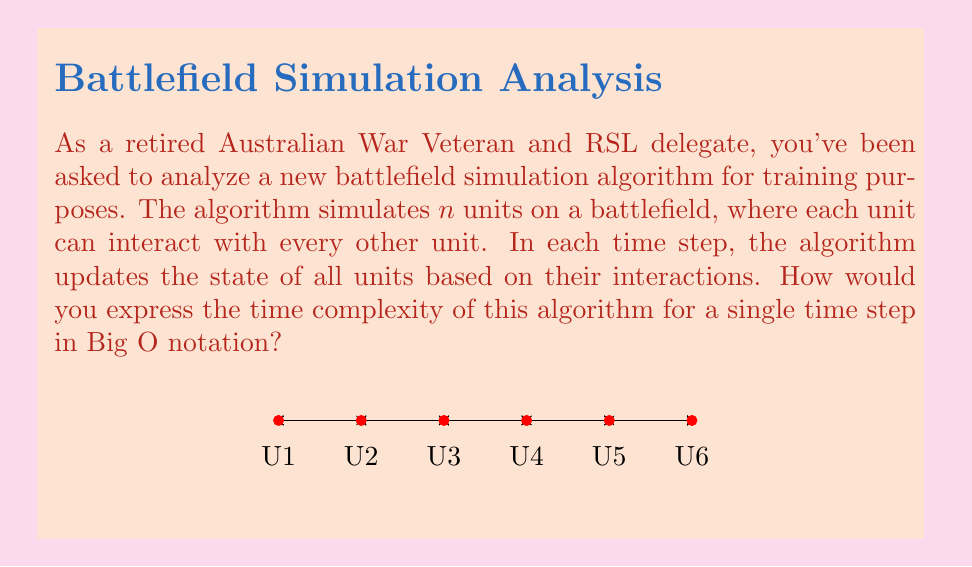Solve this math problem. Let's analyze this step-by-step:

1) In the battlefield simulation, we have $n$ units.

2) Each unit needs to interact with every other unit. This means:
   - Unit 1 interacts with $(n-1)$ units
   - Unit 2 interacts with $(n-1)$ units
   - ...
   - Unit $n$ interacts with $(n-1)$ units

3) The total number of interactions is:

   $$(n-1) + (n-1) + ... + (n-1) = n(n-1)$$

4) This can be simplified to:

   $$n^2 - n$$

5) In Big O notation, we focus on the highest order term and ignore constants. The highest order term here is $n^2$.

6) Therefore, the time complexity for a single time step is $O(n^2)$.

This quadratic time complexity reflects that each unit must consider its relationship with every other unit, resulting in a number of operations that grows with the square of the number of units.
Answer: $O(n^2)$ 